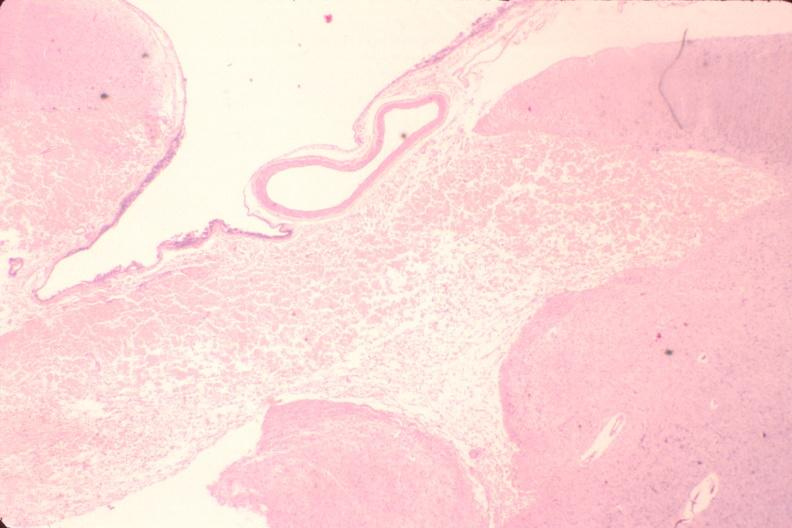what does this image show?
Answer the question using a single word or phrase. Brain 